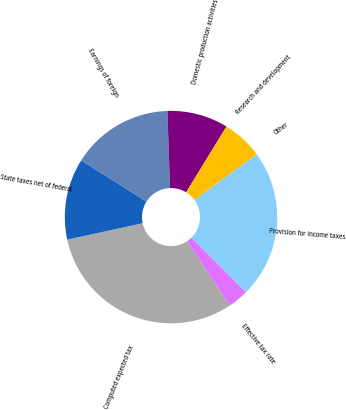<chart> <loc_0><loc_0><loc_500><loc_500><pie_chart><fcel>Computed expected tax<fcel>State taxes net of federal<fcel>Earnings of foreign<fcel>Domestic production activities<fcel>Research and development<fcel>Other<fcel>Provision for income taxes<fcel>Effective tax rate<nl><fcel>30.93%<fcel>12.38%<fcel>15.48%<fcel>9.29%<fcel>6.2%<fcel>0.02%<fcel>22.59%<fcel>3.11%<nl></chart> 